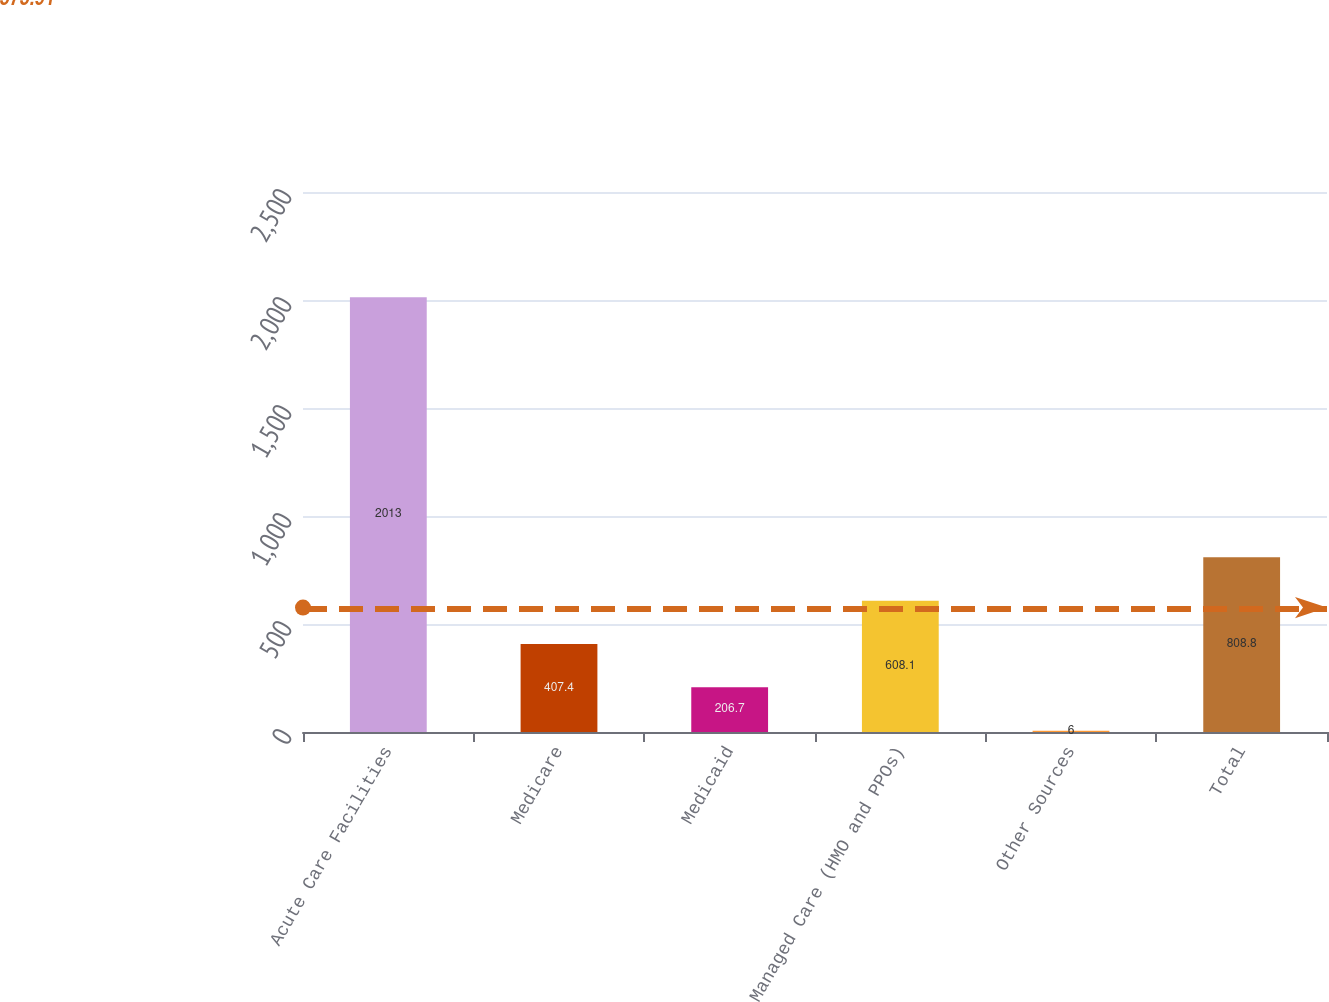<chart> <loc_0><loc_0><loc_500><loc_500><bar_chart><fcel>Acute Care Facilities<fcel>Medicare<fcel>Medicaid<fcel>Managed Care (HMO and PPOs)<fcel>Other Sources<fcel>Total<nl><fcel>2013<fcel>407.4<fcel>206.7<fcel>608.1<fcel>6<fcel>808.8<nl></chart> 